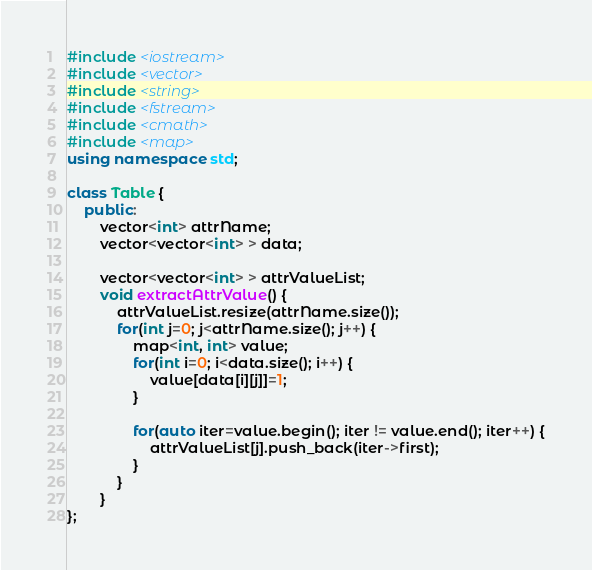<code> <loc_0><loc_0><loc_500><loc_500><_C++_>#include <iostream>
#include <vector>
#include <string>
#include <fstream>
#include <cmath>
#include <map>
using namespace std;

class Table {
	public:
		vector<int> attrName;
		vector<vector<int> > data;

		vector<vector<int> > attrValueList;
		void extractAttrValue() {
			attrValueList.resize(attrName.size());
			for(int j=0; j<attrName.size(); j++) {
				map<int, int> value;
				for(int i=0; i<data.size(); i++) {
					value[data[i][j]]=1;
				}

				for(auto iter=value.begin(); iter != value.end(); iter++) {
					attrValueList[j].push_back(iter->first);
				}
			}
		}
};


</code> 